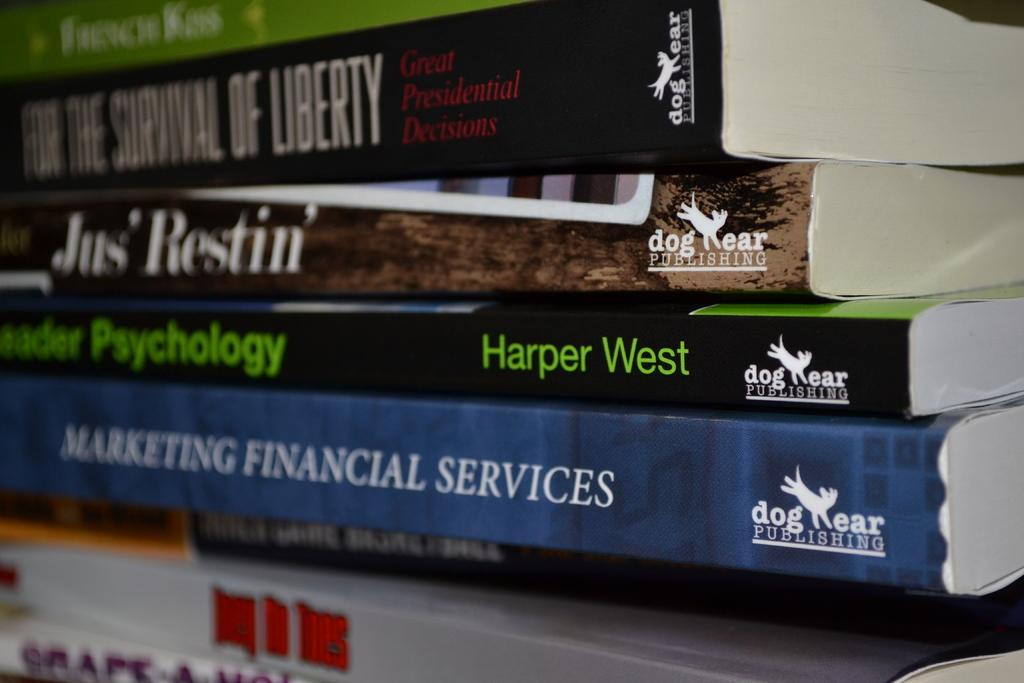Provide a one-sentence caption for the provided image. A stack of books, the bottom one saying MArketing Financial Services. 